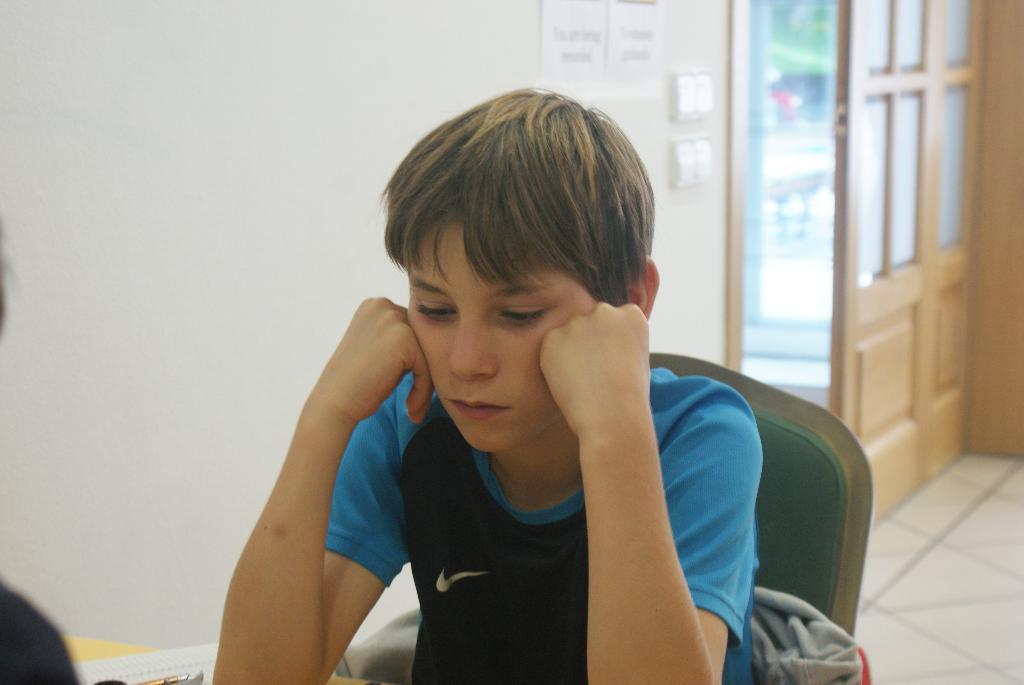How would you summarize this image in a sentence or two? In this image in front there is a person sitting on the chair. In front of him there is a table and on top of the table there is a paper and a pen. On the left side of the image there is a person. In the background of the image there is a wall with the posters on it. There are switches. There is a door. At the bottom of the image there is a floor. 